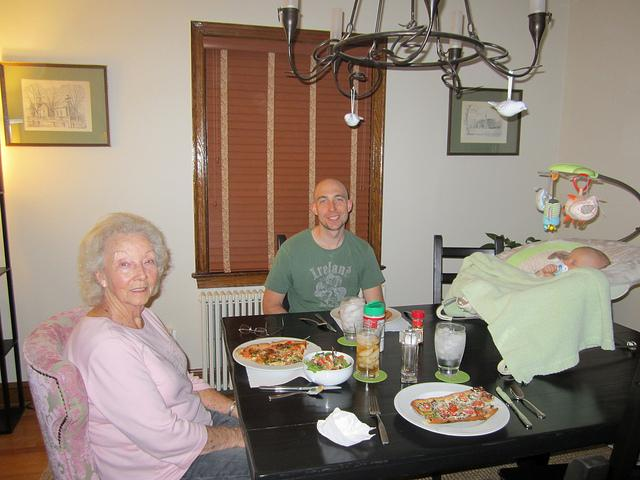What meal are the people most likely eating at the table?

Choices:
A) dessert
B) breakfast
C) dinner
D) lunch dinner 